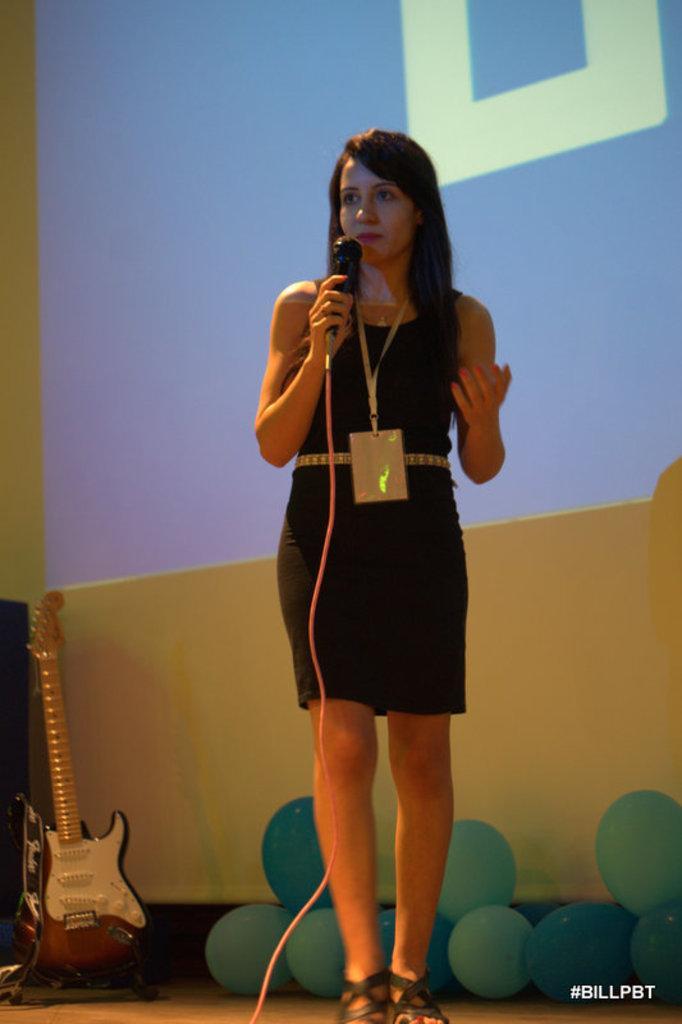Describe this image in one or two sentences. in the picture there is a woman standing and catching a micro phone with her hands,her we can see a guitar and some balloons near to her. 